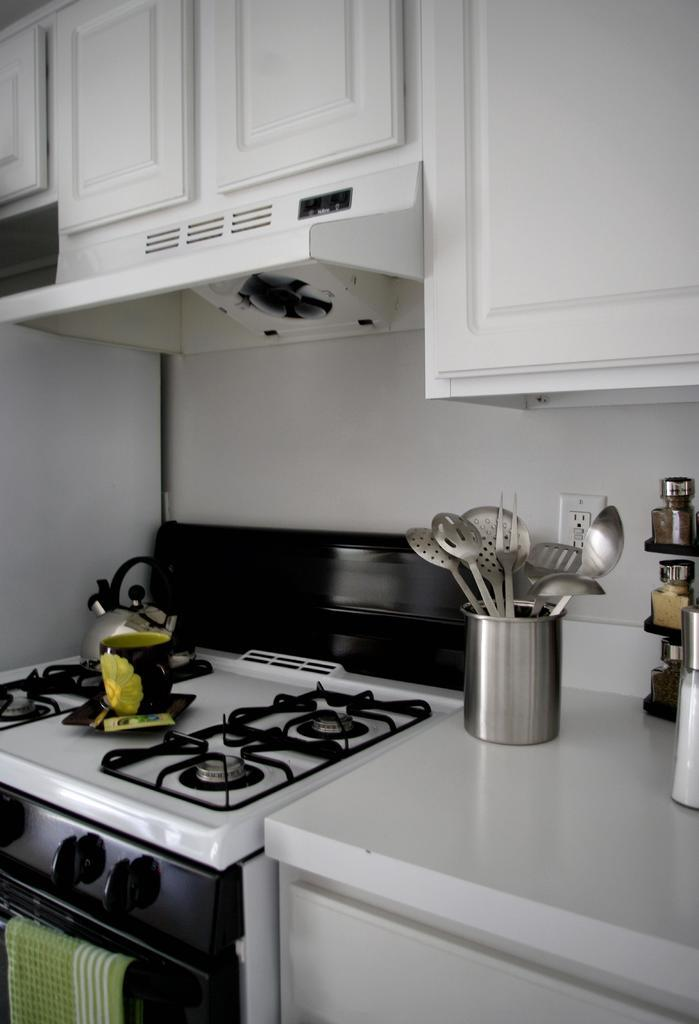What is one of the objects visible in the image? There is a cup in the image. What else can be seen in the image related to serving or eating? There are spoons in the image. What is the source of heat in the image? There is a stove in the image. What can be used to store or hold items in the image? There are jars and cupboards in the image. What is used for drying or wiping in the image? There is a towel in the image. What is the purpose of the switchboard in the image? The switchboard is used for controlling electrical devices. What is the background of the image made of? There is a wall in the image. Can you describe any unspecified objects in the image? Unfortunately, the facts provided do not specify the nature of the unspecified objects. What type of humor is being displayed by the plate in the image? There is no plate present in the image, so it is not possible to determine if any humor is being displayed. 